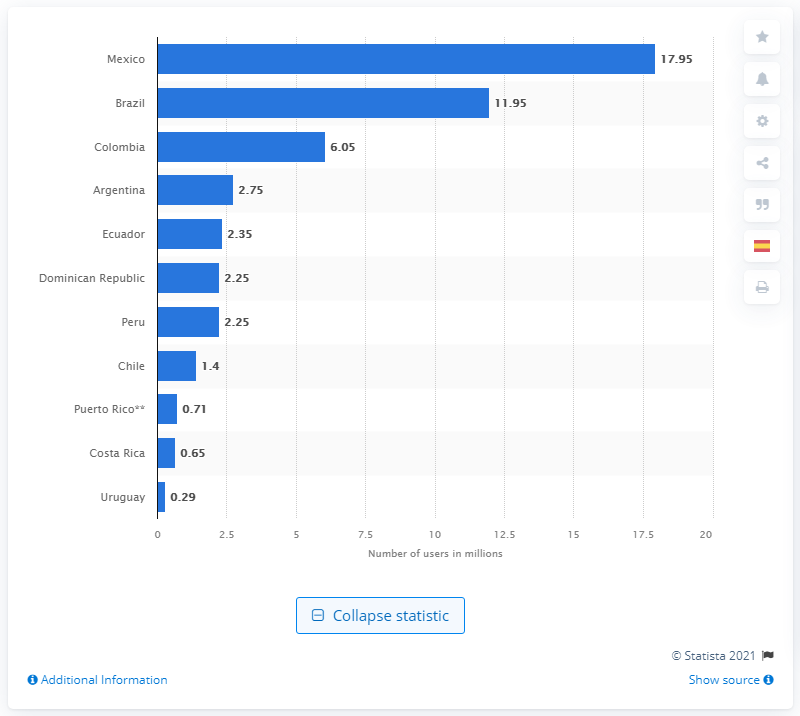Point out several critical features in this image. As of January 2021, there were 17.95 Snapchat users in Mexico. Colombia had the most Snapchat users out of all countries. 